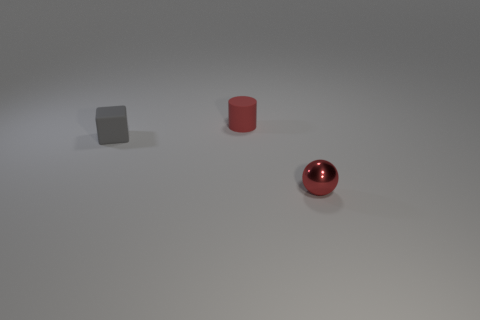Is there any other thing that has the same material as the small red sphere?
Your answer should be very brief. No. There is a cylinder that is the same color as the small ball; what is it made of?
Keep it short and to the point. Rubber. Does the object that is left of the cylinder have the same size as the thing that is to the right of the tiny cylinder?
Provide a short and direct response. Yes. What number of things are either brown blocks or tiny rubber cubes?
Provide a succinct answer. 1. What is the material of the thing right of the red thing left of the small red sphere?
Ensure brevity in your answer.  Metal. Are there any spheres that have the same color as the tiny shiny object?
Give a very brief answer. No. What number of things are either tiny matte things behind the tiny gray rubber thing or small objects in front of the small red matte cylinder?
Keep it short and to the point. 3. Is there a gray cube that is on the right side of the tiny red object to the left of the red metal ball?
Ensure brevity in your answer.  No. The red shiny object that is the same size as the cylinder is what shape?
Provide a short and direct response. Sphere. How many things are either objects behind the tiny red sphere or balls?
Your answer should be very brief. 3. 